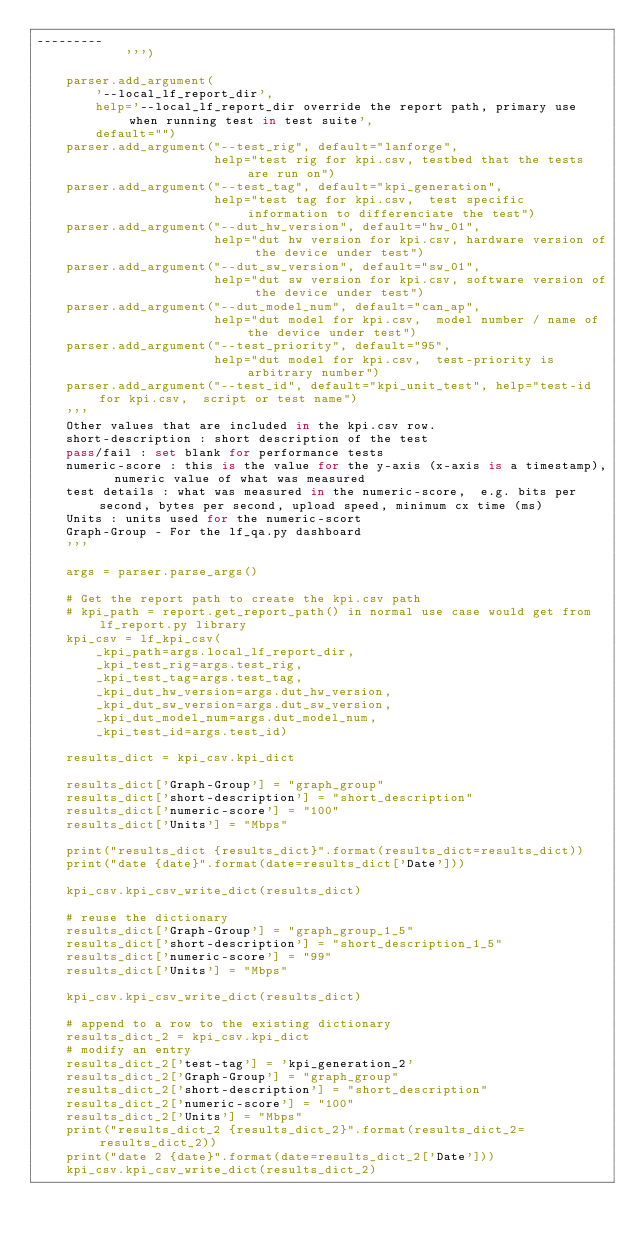<code> <loc_0><loc_0><loc_500><loc_500><_Python_>---------
            ''')

    parser.add_argument(
        '--local_lf_report_dir',
        help='--local_lf_report_dir override the report path, primary use when running test in test suite',
        default="")
    parser.add_argument("--test_rig", default="lanforge",
                        help="test rig for kpi.csv, testbed that the tests are run on")
    parser.add_argument("--test_tag", default="kpi_generation",
                        help="test tag for kpi.csv,  test specific information to differenciate the test")
    parser.add_argument("--dut_hw_version", default="hw_01",
                        help="dut hw version for kpi.csv, hardware version of the device under test")
    parser.add_argument("--dut_sw_version", default="sw_01",
                        help="dut sw version for kpi.csv, software version of the device under test")
    parser.add_argument("--dut_model_num", default="can_ap",
                        help="dut model for kpi.csv,  model number / name of the device under test")
    parser.add_argument("--test_priority", default="95",
                        help="dut model for kpi.csv,  test-priority is arbitrary number")
    parser.add_argument("--test_id", default="kpi_unit_test", help="test-id for kpi.csv,  script or test name")
    '''
    Other values that are included in the kpi.csv row.
    short-description : short description of the test
    pass/fail : set blank for performance tests
    numeric-score : this is the value for the y-axis (x-axis is a timestamp),  numeric value of what was measured
    test details : what was measured in the numeric-score,  e.g. bits per second, bytes per second, upload speed, minimum cx time (ms)
    Units : units used for the numeric-scort
    Graph-Group - For the lf_qa.py dashboard
    '''

    args = parser.parse_args()

    # Get the report path to create the kpi.csv path
    # kpi_path = report.get_report_path() in normal use case would get from lf_report.py library
    kpi_csv = lf_kpi_csv(
        _kpi_path=args.local_lf_report_dir,
        _kpi_test_rig=args.test_rig,
        _kpi_test_tag=args.test_tag,
        _kpi_dut_hw_version=args.dut_hw_version,
        _kpi_dut_sw_version=args.dut_sw_version,
        _kpi_dut_model_num=args.dut_model_num,
        _kpi_test_id=args.test_id)

    results_dict = kpi_csv.kpi_dict

    results_dict['Graph-Group'] = "graph_group"
    results_dict['short-description'] = "short_description"
    results_dict['numeric-score'] = "100"
    results_dict['Units'] = "Mbps"

    print("results_dict {results_dict}".format(results_dict=results_dict))
    print("date {date}".format(date=results_dict['Date']))

    kpi_csv.kpi_csv_write_dict(results_dict)

    # reuse the dictionary
    results_dict['Graph-Group'] = "graph_group_1_5"
    results_dict['short-description'] = "short_description_1_5"
    results_dict['numeric-score'] = "99"
    results_dict['Units'] = "Mbps"

    kpi_csv.kpi_csv_write_dict(results_dict)

    # append to a row to the existing dictionary
    results_dict_2 = kpi_csv.kpi_dict
    # modify an entry
    results_dict_2['test-tag'] = 'kpi_generation_2'
    results_dict_2['Graph-Group'] = "graph_group"
    results_dict_2['short-description'] = "short_description"
    results_dict_2['numeric-score'] = "100"
    results_dict_2['Units'] = "Mbps"
    print("results_dict_2 {results_dict_2}".format(results_dict_2=results_dict_2))
    print("date 2 {date}".format(date=results_dict_2['Date']))
    kpi_csv.kpi_csv_write_dict(results_dict_2)

</code> 